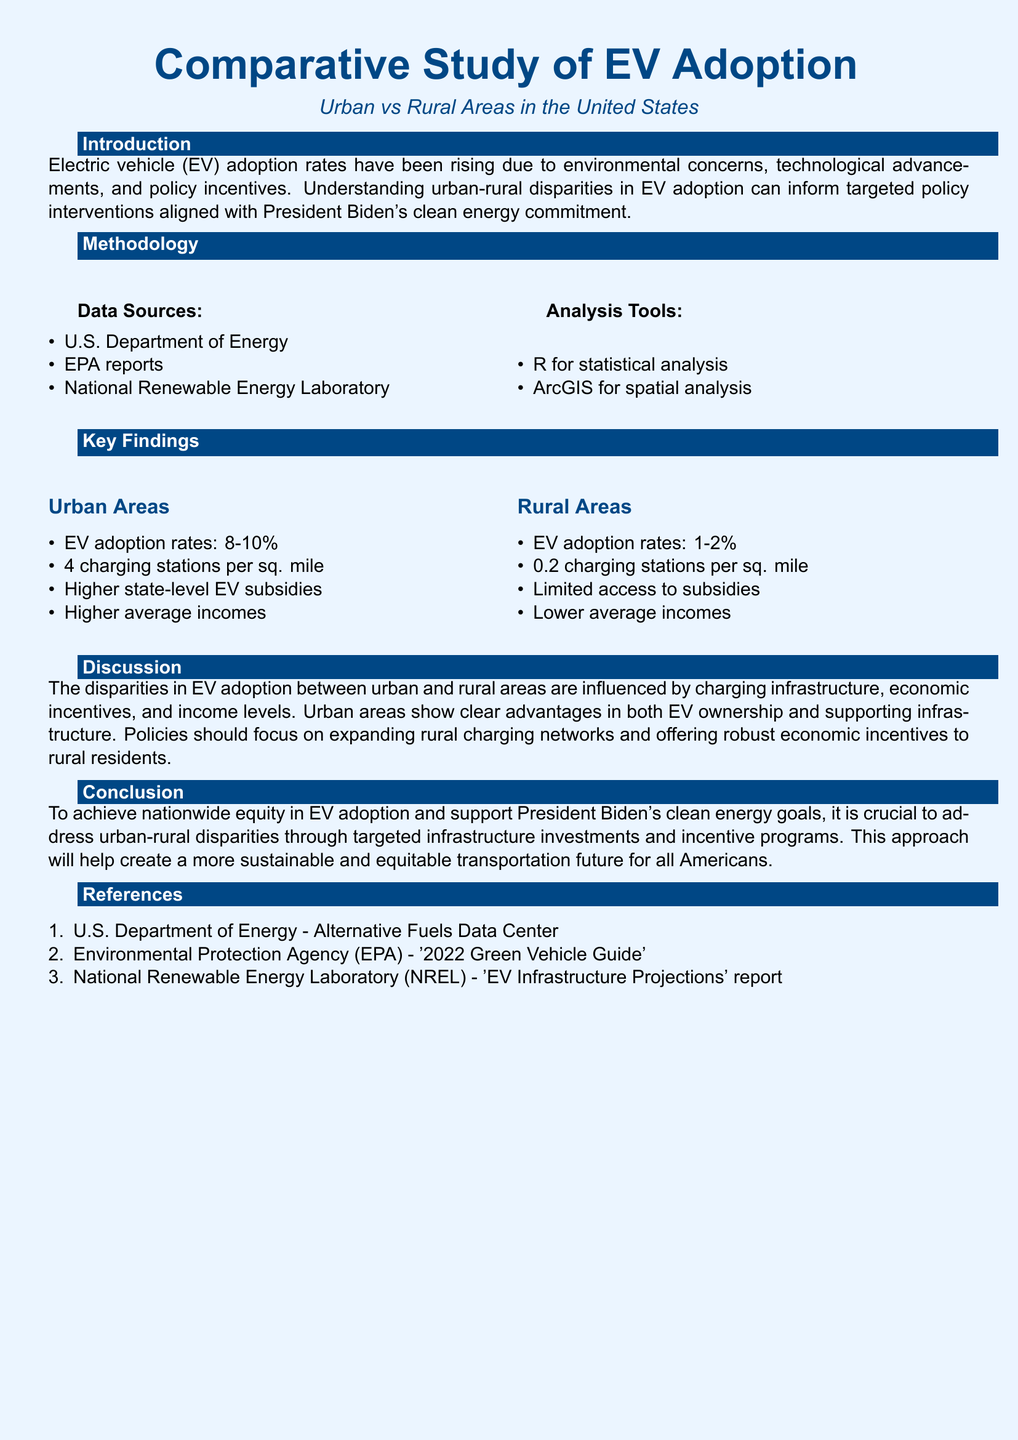what are the electric vehicle adoption rates in urban areas? The document states that the EV adoption rates in urban areas range from 8 to 10 percent.
Answer: 8-10 percent what are the electric vehicle adoption rates in rural areas? The document indicates that the EV adoption rates in rural areas range from 1 to 2 percent.
Answer: 1-2 percent how many charging stations are there per square mile in urban areas? The report mentions there are 4 charging stations per square mile in urban areas.
Answer: 4 charging stations how many charging stations are there per square mile in rural areas? According to the document, there are 0.2 charging stations per square mile in rural areas.
Answer: 0.2 charging stations which government body provides data for the study? The methodology section lists the U.S. Department of Energy as a data source.
Answer: U.S. Department of Energy what analytical tools were used in the study? The analysis tools mentioned in the document are R for statistical analysis and ArcGIS for spatial analysis.
Answer: R and ArcGIS why do urban areas have higher EV adoption rates than rural areas? The discussion notes that urban areas have advantages in charging infrastructure, economic incentives, and income levels.
Answer: Charging infrastructure, economic incentives, income levels what should policies focus on to improve EV adoption in rural areas? The document suggests that policies should focus on expanding rural charging networks and offering robust economic incentives.
Answer: Expanding rural charging networks, robust economic incentives what is the primary goal of the study? The conclusion states that the goal is to address urban-rural disparities in EV adoption to support clean energy goals.
Answer: Address urban-rural disparities to support clean energy goals 